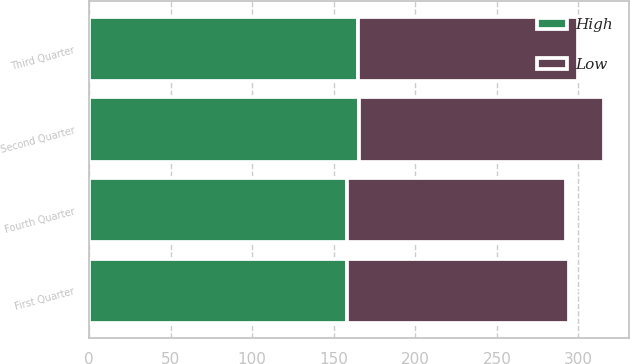<chart> <loc_0><loc_0><loc_500><loc_500><stacked_bar_chart><ecel><fcel>First Quarter<fcel>Second Quarter<fcel>Third Quarter<fcel>Fourth Quarter<nl><fcel>High<fcel>158.45<fcel>165.67<fcel>164.61<fcel>157.97<nl><fcel>Low<fcel>135.73<fcel>149.75<fcel>135.16<fcel>134.55<nl></chart> 